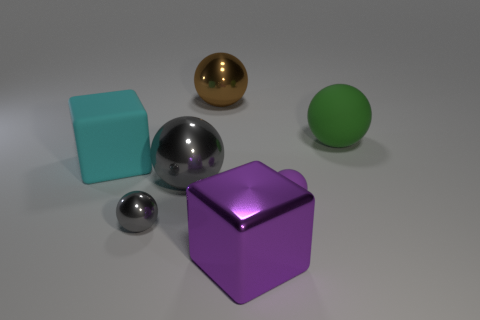Are there fewer purple blocks than metal objects?
Make the answer very short. Yes. Are there more rubber things that are in front of the cyan matte thing than metal spheres that are to the right of the brown metal thing?
Ensure brevity in your answer.  Yes. Do the tiny gray thing and the small purple object have the same material?
Offer a very short reply. No. There is a big cube that is behind the small gray sphere; how many metal spheres are behind it?
Give a very brief answer. 1. There is a large ball left of the big brown shiny ball; is it the same color as the tiny metallic object?
Make the answer very short. Yes. How many things are either small yellow rubber spheres or large matte things that are in front of the large green rubber sphere?
Provide a short and direct response. 1. There is a large object behind the big green ball; does it have the same shape as the big shiny object left of the brown metallic ball?
Keep it short and to the point. Yes. Is there anything else that is the same color as the metallic block?
Provide a short and direct response. Yes. What shape is the big cyan thing that is the same material as the green ball?
Offer a terse response. Cube. What is the material of the thing that is in front of the tiny matte object and to the left of the purple shiny cube?
Your answer should be very brief. Metal. 